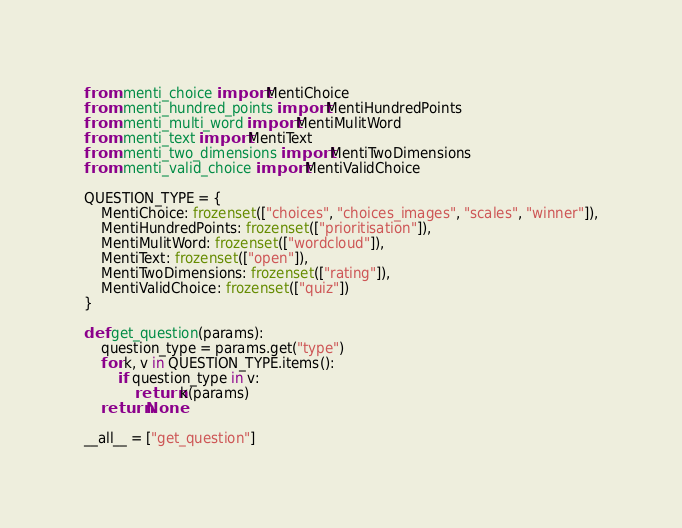Convert code to text. <code><loc_0><loc_0><loc_500><loc_500><_Python_>from .menti_choice import MentiChoice
from .menti_hundred_points import MentiHundredPoints
from .menti_multi_word import MentiMulitWord
from .menti_text import MentiText
from .menti_two_dimensions import MentiTwoDimensions
from .menti_valid_choice import MentiValidChoice

QUESTION_TYPE = {
    MentiChoice: frozenset(["choices", "choices_images", "scales", "winner"]),
    MentiHundredPoints: frozenset(["prioritisation"]),
    MentiMulitWord: frozenset(["wordcloud"]),
    MentiText: frozenset(["open"]),
    MentiTwoDimensions: frozenset(["rating"]),
    MentiValidChoice: frozenset(["quiz"])
}

def get_question(params):
    question_type = params.get("type")
    for k, v in QUESTION_TYPE.items():
        if question_type in v:
            return k(params)
    return None

__all__ = ["get_question"]
</code> 